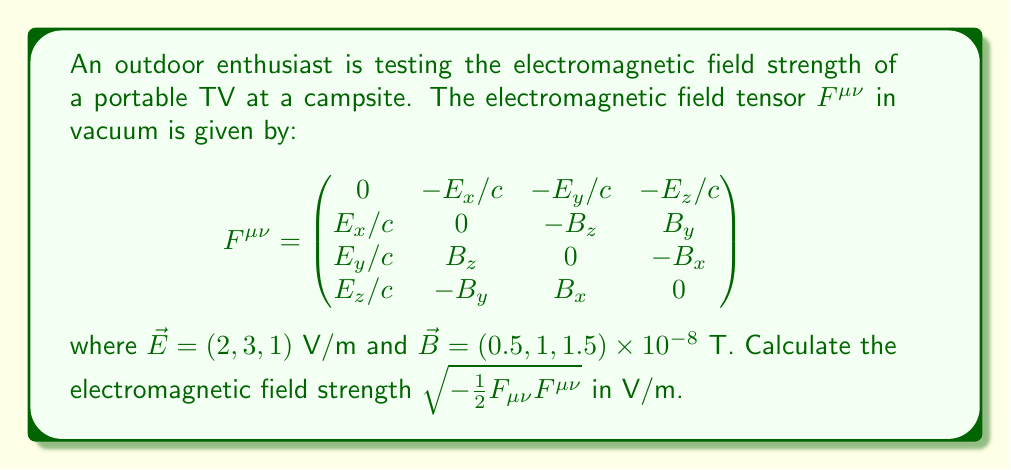Give your solution to this math problem. To solve this problem, we'll follow these steps:

1) First, we need to lower one index of $F^{\mu\nu}$ to get $F_{\mu\nu}$. In Minkowski space, this is done by multiplying by the metric tensor $g_{\mu\nu} = \text{diag}(-1, 1, 1, 1)$:

   $F_{\mu\nu} = g_{\mu\alpha}g_{\nu\beta}F^{\alpha\beta}$

2) This operation changes the signs of the electric field components:

   $$F_{\mu\nu} = \begin{pmatrix}
   0 & E_x/c & E_y/c & E_z/c \\
   -E_x/c & 0 & -B_z & B_y \\
   -E_y/c & B_z & 0 & -B_x \\
   -E_z/c & -B_y & B_x & 0
   \end{pmatrix}$$

3) Now we need to calculate $F_{\mu\nu}F^{\mu\nu}$. This is a contraction of indices, which means we multiply corresponding elements and sum:

   $F_{\mu\nu}F^{\mu\nu} = 2[(E_x/c)^2 + (E_y/c)^2 + (E_z/c)^2 - B_x^2 - B_y^2 - B_z^2]$

4) Let's substitute the values (note that $c \approx 3 \times 10^8$ m/s):

   $F_{\mu\nu}F^{\mu\nu} = 2[(2/c)^2 + (3/c)^2 + (1/c)^2 - (0.5 \times 10^{-8})^2 - (1 \times 10^{-8})^2 - (1.5 \times 10^{-8})^2]$

5) The $B$ terms are negligibly small compared to the $E$ terms, so we can ignore them:

   $F_{\mu\nu}F^{\mu\nu} \approx 2[(2/c)^2 + (3/c)^2 + (1/c)^2] = 2(14/c^2) = 28/c^2$

6) Now we can calculate the field strength:

   $\text{Field Strength} = \sqrt{-\frac{1}{2}F_{\mu\nu}F^{\mu\nu}} = \sqrt{-\frac{1}{2}(-28/c^2)} = \sqrt{14}/c$

7) Substituting $c \approx 3 \times 10^8$ m/s:

   $\text{Field Strength} \approx \frac{\sqrt{14}}{3 \times 10^8} \approx 3.94 \times 10^{-9}$ V/m
Answer: $3.94 \times 10^{-9}$ V/m 